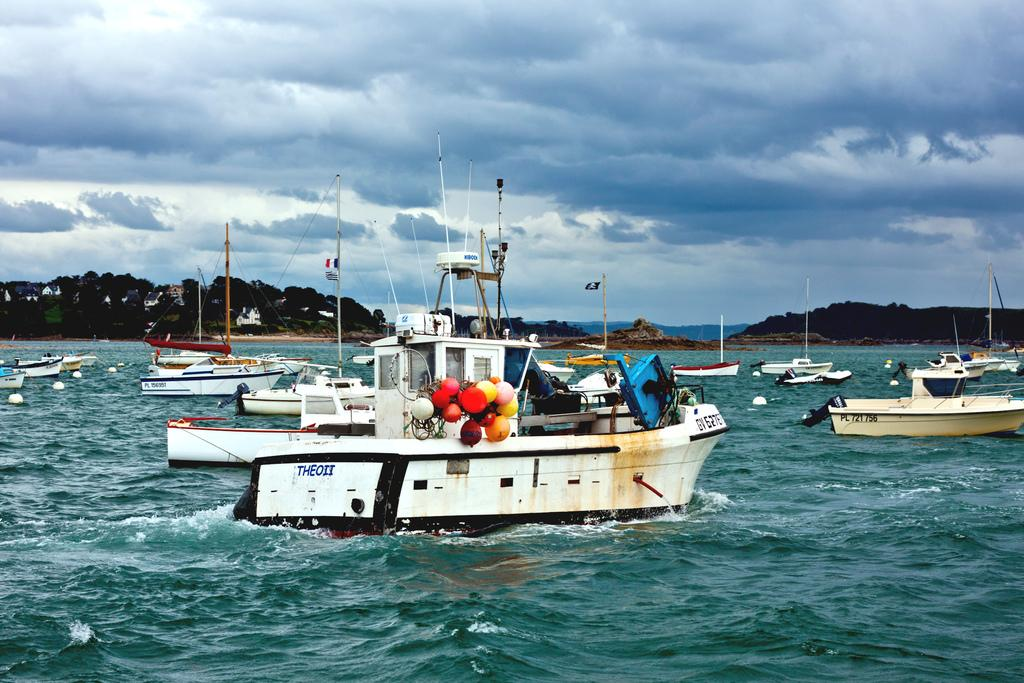What color are the boats in the image? The boats in the image are white. What can be seen in the background of the image? There are mountains in the background of the image. What is visible in the sky in the image? There are clouds in the sky. Is there a beggar asking for money near the boats in the image? There is no beggar present in the image. What type of rod can be seen being used by the boats in the image? There are no rods visible in the image; the boats are on the water. 